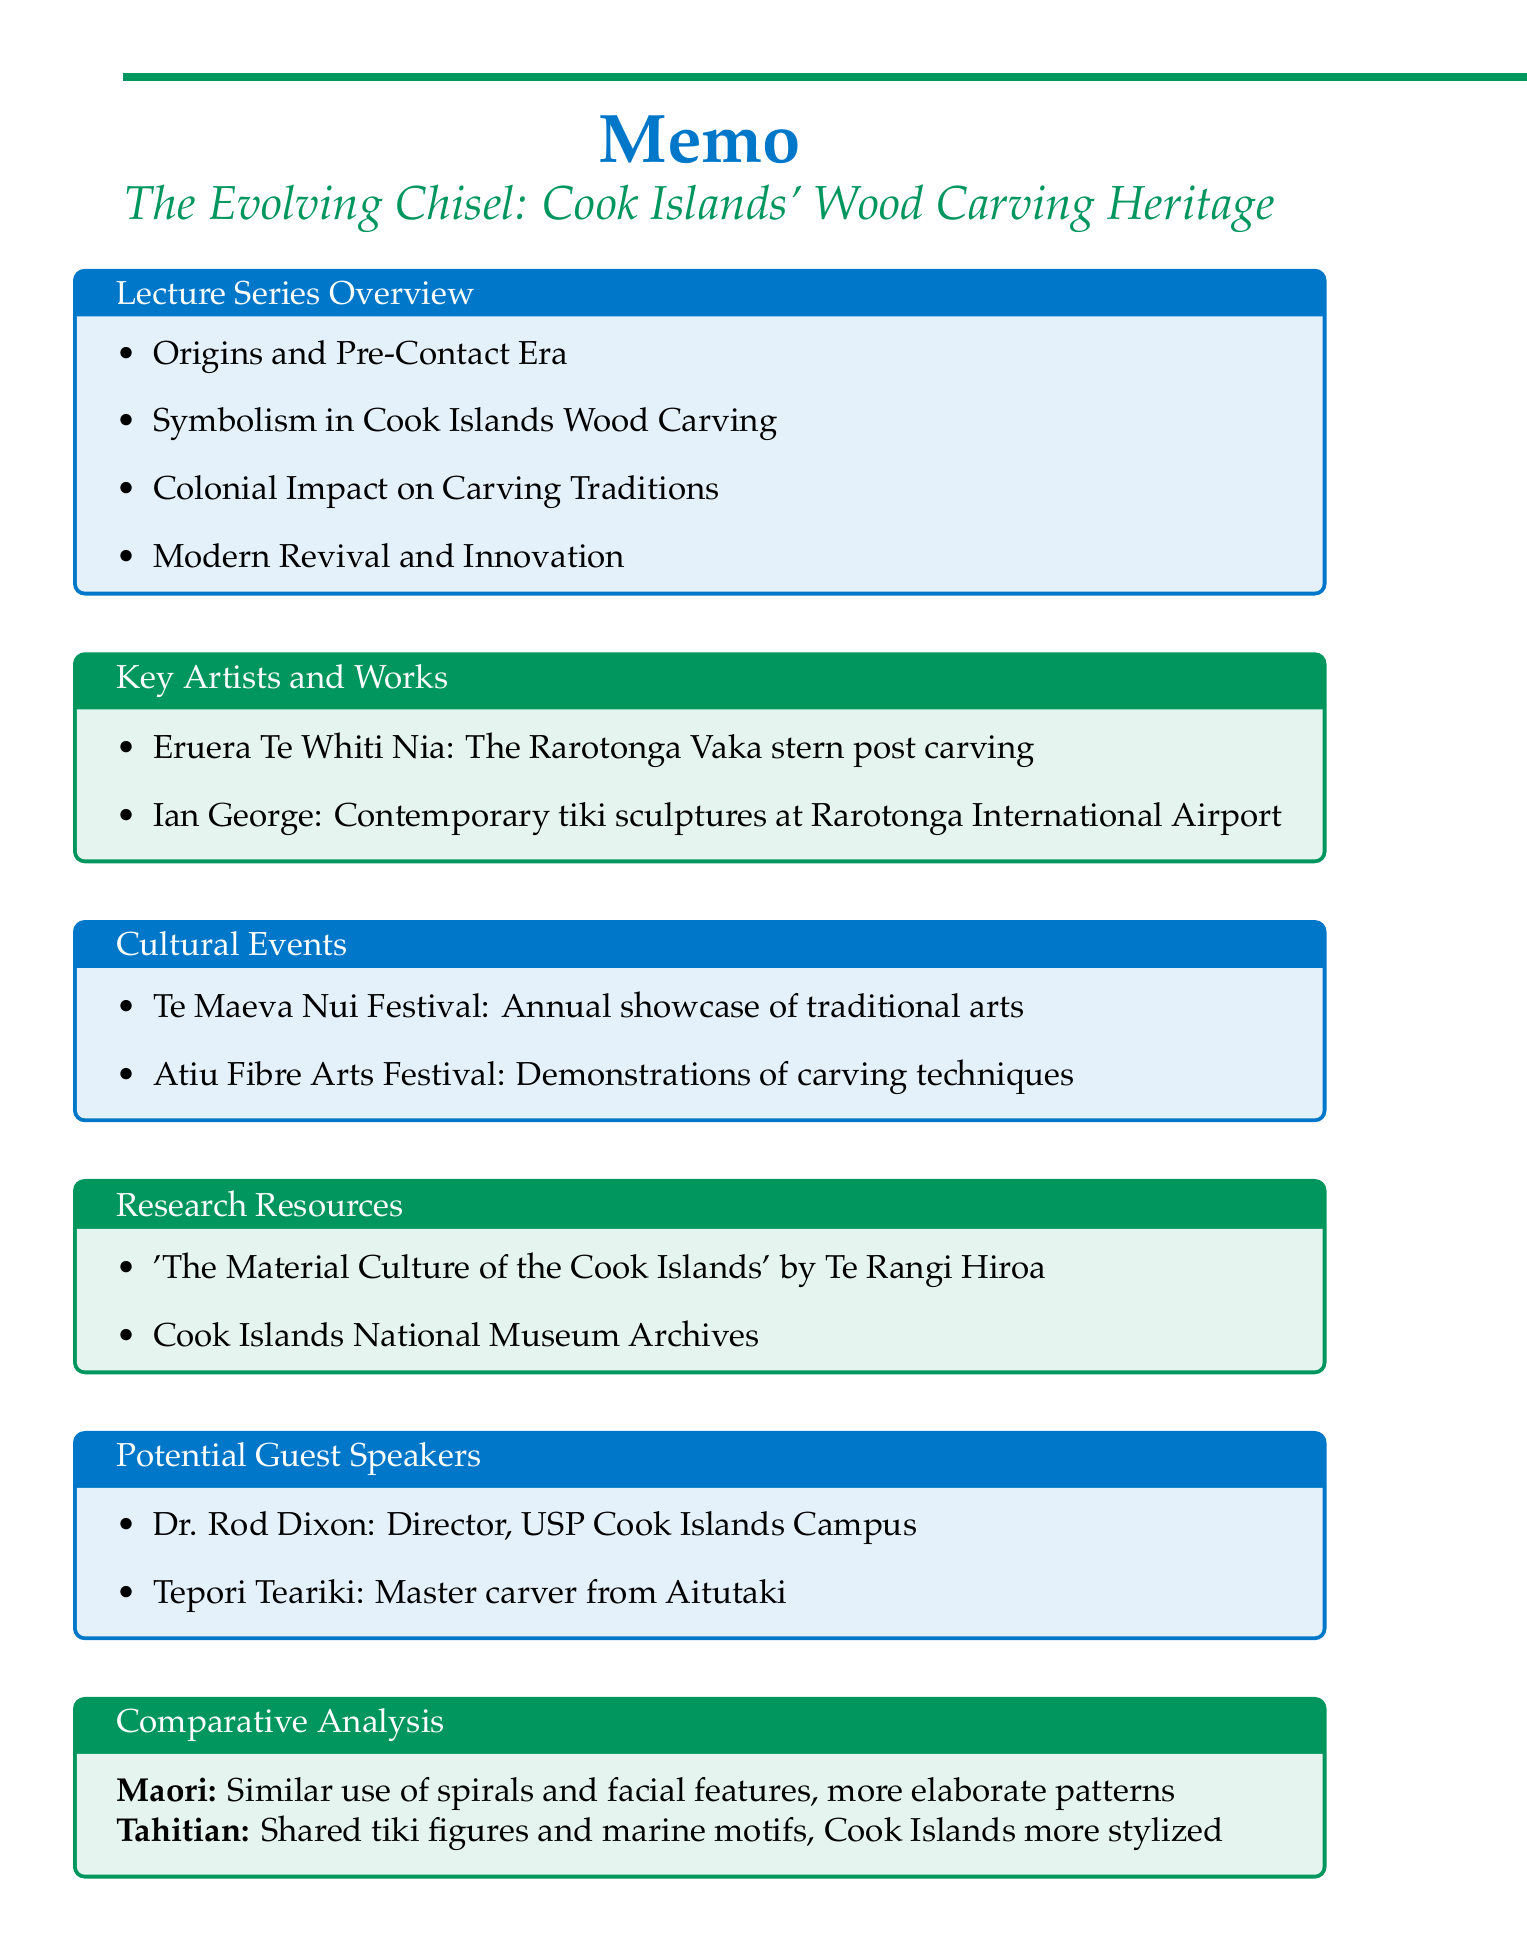what is the title of the lecture series? The title of the lecture series is stated at the beginning of the memo.
Answer: The Evolving Chisel: Cook Islands' Wood Carving Heritage who is a notable artist mentioned in the memo? The memo lists key artists in the section dedicated to artists and their notable works.
Answer: Eruera Te Whiti Nia what is the significance of tikis in Cook Islands wood carving? The memo describes the symbolic meanings in wood carving and highlights the significance of tikis in that context.
Answer: The significance of the 'tikis' and their various forms how many topics are listed in the lecture series overview? The memo outlines the main topics covered in the lecture series.
Answer: Four which festival is an annual showcase of traditional Cook Islands arts? The memo includes cultural events and their relevance to Cook Islands arts, specifically wood carving.
Answer: Te Maeva Nui Festival who is a potential guest speaker known for expertise in Cook Islands culture? The memo provides information about potential speakers, including their expertise.
Answer: Dr. Rod Dixon what is a similarity between Cook Islands and Maori carvings? The comparative analysis section discusses similarities and differences between cultures' carving traditions.
Answer: Use of spirals and facial features in carvings which resource contains historical records and photographs of carving traditions? The memo lists research resources relevant to the lecture series, including key documents.
Answer: Cook Islands National Museum Archives 